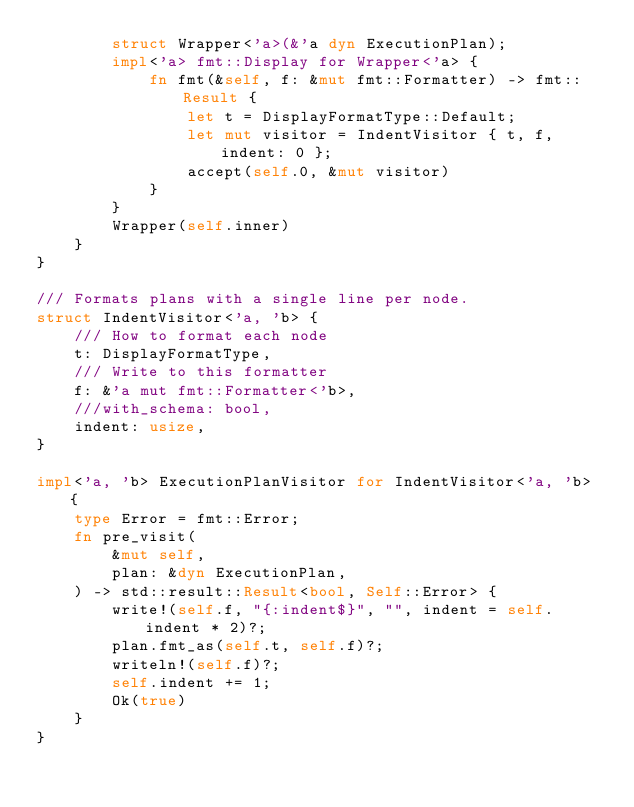<code> <loc_0><loc_0><loc_500><loc_500><_Rust_>        struct Wrapper<'a>(&'a dyn ExecutionPlan);
        impl<'a> fmt::Display for Wrapper<'a> {
            fn fmt(&self, f: &mut fmt::Formatter) -> fmt::Result {
                let t = DisplayFormatType::Default;
                let mut visitor = IndentVisitor { t, f, indent: 0 };
                accept(self.0, &mut visitor)
            }
        }
        Wrapper(self.inner)
    }
}

/// Formats plans with a single line per node.
struct IndentVisitor<'a, 'b> {
    /// How to format each node
    t: DisplayFormatType,
    /// Write to this formatter
    f: &'a mut fmt::Formatter<'b>,
    ///with_schema: bool,
    indent: usize,
}

impl<'a, 'b> ExecutionPlanVisitor for IndentVisitor<'a, 'b> {
    type Error = fmt::Error;
    fn pre_visit(
        &mut self,
        plan: &dyn ExecutionPlan,
    ) -> std::result::Result<bool, Self::Error> {
        write!(self.f, "{:indent$}", "", indent = self.indent * 2)?;
        plan.fmt_as(self.t, self.f)?;
        writeln!(self.f)?;
        self.indent += 1;
        Ok(true)
    }
}
</code> 